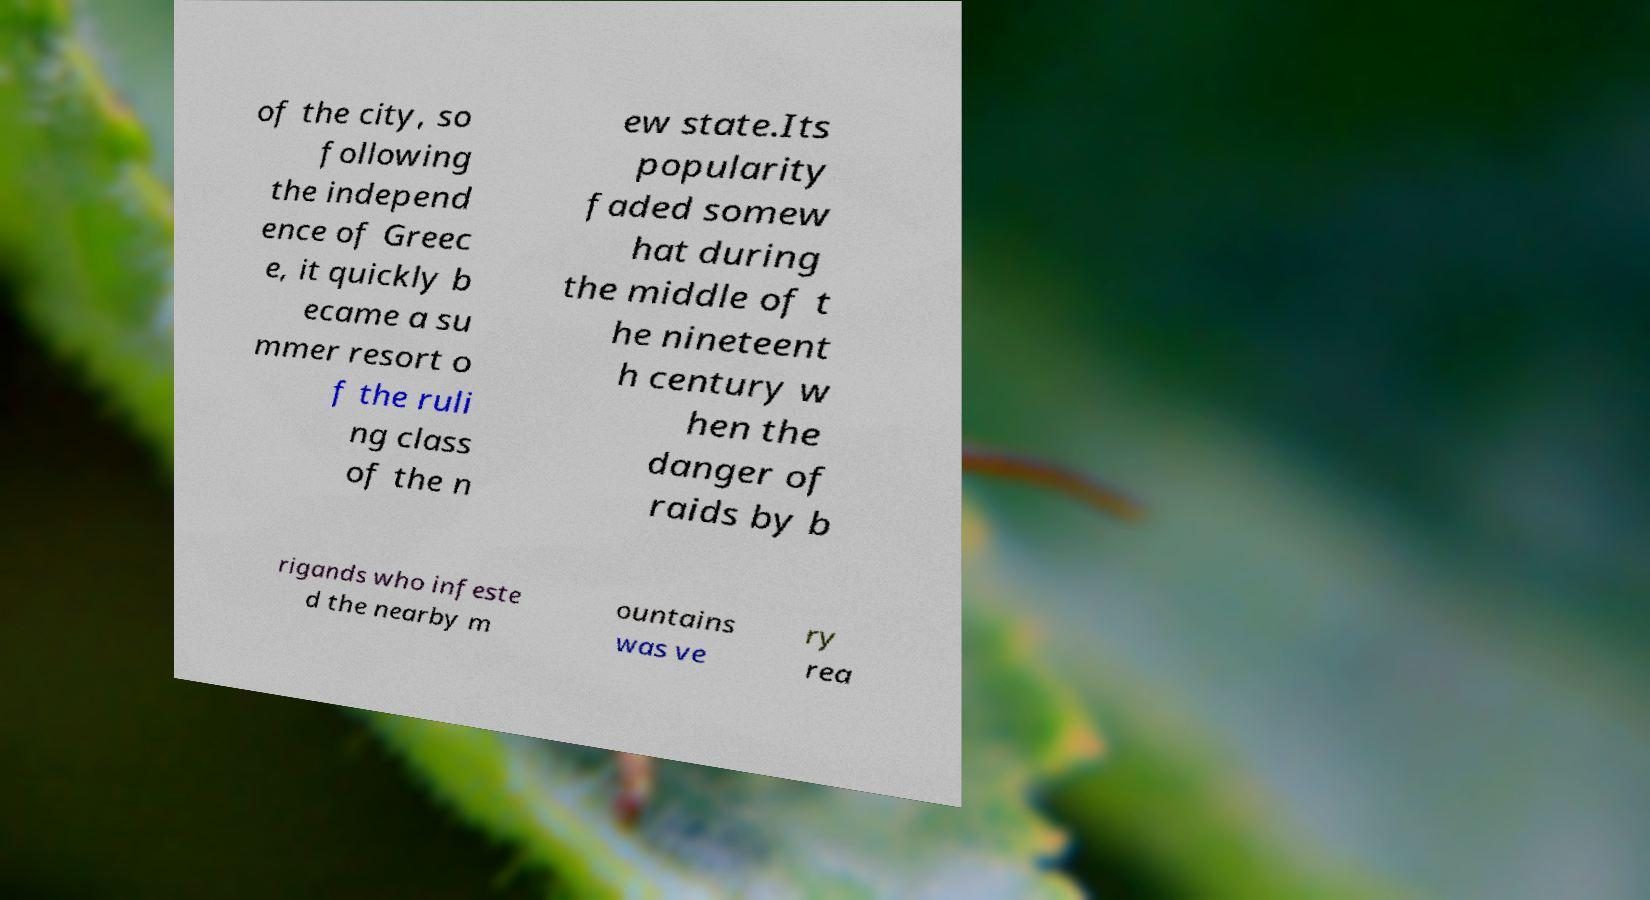For documentation purposes, I need the text within this image transcribed. Could you provide that? of the city, so following the independ ence of Greec e, it quickly b ecame a su mmer resort o f the ruli ng class of the n ew state.Its popularity faded somew hat during the middle of t he nineteent h century w hen the danger of raids by b rigands who infeste d the nearby m ountains was ve ry rea 